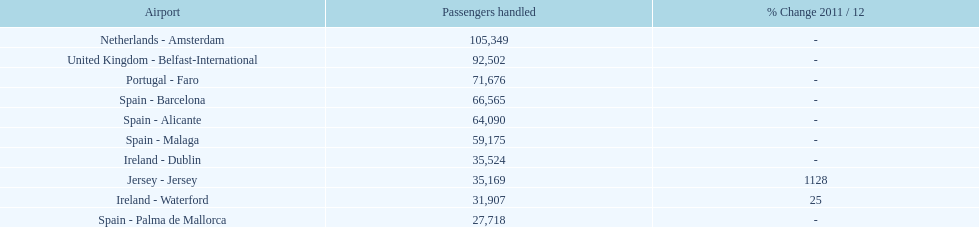What is the name of the only airport in portugal that is among the 10 busiest routes to and from london southend airport in 2012? Portugal - Faro. 